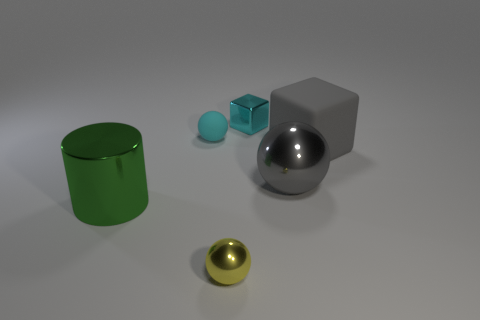Add 4 cyan matte things. How many objects exist? 10 Subtract all metal spheres. How many spheres are left? 1 Subtract 1 cylinders. How many cylinders are left? 0 Subtract all green balls. How many blue cylinders are left? 0 Subtract all big green balls. Subtract all small cubes. How many objects are left? 5 Add 5 big metallic cylinders. How many big metallic cylinders are left? 6 Add 1 gray blocks. How many gray blocks exist? 2 Subtract all gray blocks. How many blocks are left? 1 Subtract 0 blue blocks. How many objects are left? 6 Subtract all cubes. How many objects are left? 4 